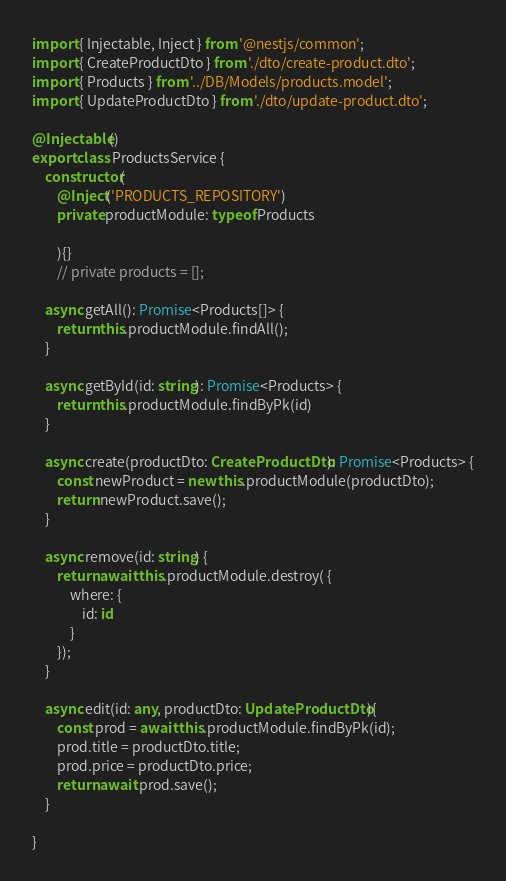<code> <loc_0><loc_0><loc_500><loc_500><_TypeScript_>import { Injectable, Inject } from '@nestjs/common';
import { CreateProductDto } from './dto/create-product.dto';
import { Products } from '../DB/Models/products.model';
import { UpdateProductDto } from './dto/update-product.dto';

@Injectable()
export class ProductsService {
    constructor(
        @Inject('PRODUCTS_REPOSITORY')
        private productModule: typeof Products
        
        ){}
        // private products = [];

    async getAll(): Promise<Products[]> {
        return this.productModule.findAll();
    }

    async getById(id: string): Promise<Products> {
        return this.productModule.findByPk(id)
    }

    async create(productDto: CreateProductDto): Promise<Products> {
        const newProduct = new this.productModule(productDto); 
        return newProduct.save();
    }

    async remove(id: string) {
        return await this.productModule.destroy( {
            where: {
                id: id
            }
        });
    }

    async edit(id: any, productDto: UpdateProductDto){  
        const prod = await this.productModule.findByPk(id);
        prod.title = productDto.title;
        prod.price = productDto.price;
        return await prod.save();
    }   

}
</code> 